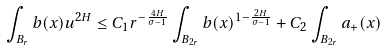Convert formula to latex. <formula><loc_0><loc_0><loc_500><loc_500>\int _ { B _ { r } } b ( x ) u ^ { 2 H } \leq { C _ { 1 } } { r ^ { - \frac { 4 H } { \sigma - 1 } } } \int _ { B _ { 2 r } } b ( x ) ^ { 1 - \frac { 2 H } { \sigma - 1 } } + C _ { 2 } \int _ { B _ { 2 r } } a _ { + } ( x )</formula> 